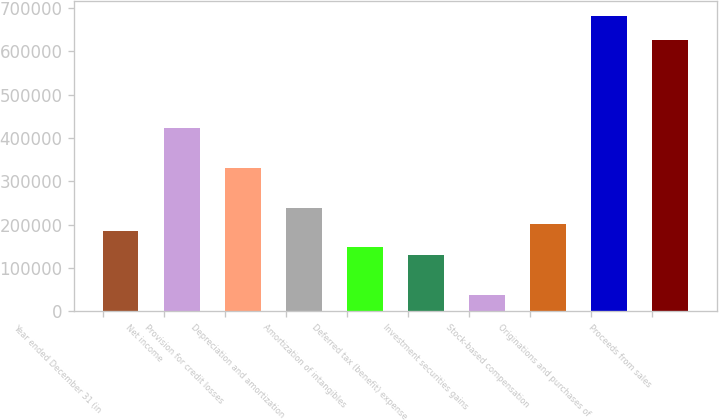Convert chart to OTSL. <chart><loc_0><loc_0><loc_500><loc_500><bar_chart><fcel>Year ended December 31 (in<fcel>Net income<fcel>Provision for credit losses<fcel>Depreciation and amortization<fcel>Amortization of intangibles<fcel>Deferred tax (benefit) expense<fcel>Investment securities gains<fcel>Stock-based compensation<fcel>Originations and purchases of<fcel>Proceeds from sales<nl><fcel>184056<fcel>423311<fcel>331290<fcel>239269<fcel>147248<fcel>128843<fcel>36822.4<fcel>202460<fcel>680969<fcel>625757<nl></chart> 